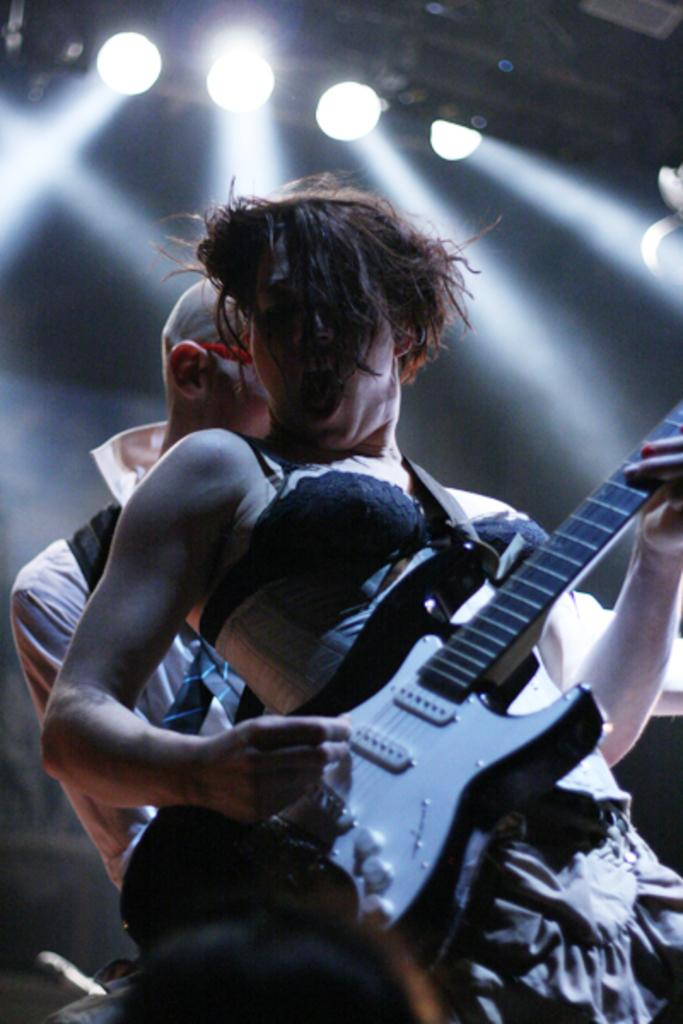What is the woman in the image doing? The woman is playing a guitar in the image. Who else is present in the image? There is a man in the image. What can be seen in the background or surrounding the subjects? There are lights visible in the image. Is the woman in the image jumping and waving while reading a book? No, the woman is playing a guitar, and there is no indication of her jumping, waving, or reading a book in the image. 